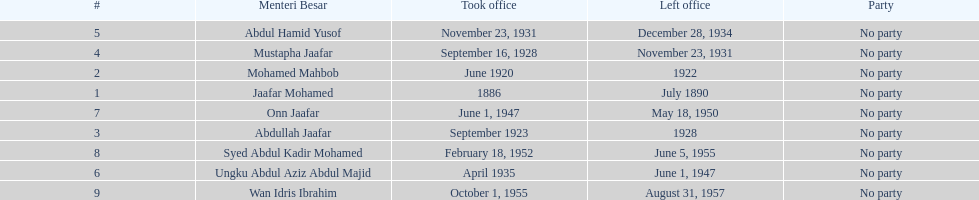Other than abullah jaafar, name someone with the same last name. Mustapha Jaafar. 